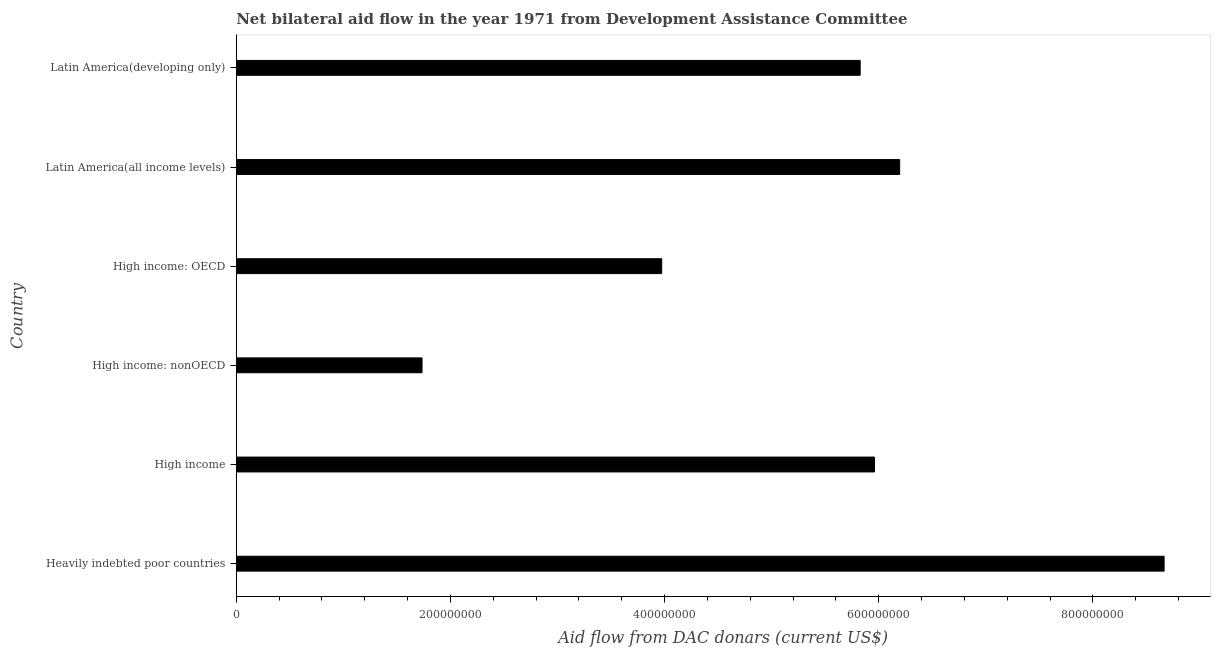What is the title of the graph?
Your answer should be very brief. Net bilateral aid flow in the year 1971 from Development Assistance Committee. What is the label or title of the X-axis?
Your response must be concise. Aid flow from DAC donars (current US$). What is the net bilateral aid flows from dac donors in Latin America(all income levels)?
Your answer should be compact. 6.20e+08. Across all countries, what is the maximum net bilateral aid flows from dac donors?
Your response must be concise. 8.66e+08. Across all countries, what is the minimum net bilateral aid flows from dac donors?
Your answer should be compact. 1.73e+08. In which country was the net bilateral aid flows from dac donors maximum?
Provide a succinct answer. Heavily indebted poor countries. In which country was the net bilateral aid flows from dac donors minimum?
Offer a very short reply. High income: nonOECD. What is the sum of the net bilateral aid flows from dac donors?
Keep it short and to the point. 3.24e+09. What is the difference between the net bilateral aid flows from dac donors in High income: nonOECD and Latin America(developing only)?
Provide a succinct answer. -4.09e+08. What is the average net bilateral aid flows from dac donors per country?
Your answer should be compact. 5.39e+08. What is the median net bilateral aid flows from dac donors?
Your answer should be very brief. 5.89e+08. What is the ratio of the net bilateral aid flows from dac donors in High income: nonOECD to that in Latin America(developing only)?
Offer a terse response. 0.3. What is the difference between the highest and the second highest net bilateral aid flows from dac donors?
Ensure brevity in your answer.  2.47e+08. Is the sum of the net bilateral aid flows from dac donors in High income: OECD and Latin America(all income levels) greater than the maximum net bilateral aid flows from dac donors across all countries?
Provide a succinct answer. Yes. What is the difference between the highest and the lowest net bilateral aid flows from dac donors?
Keep it short and to the point. 6.93e+08. How many bars are there?
Offer a terse response. 6. What is the Aid flow from DAC donars (current US$) in Heavily indebted poor countries?
Keep it short and to the point. 8.66e+08. What is the Aid flow from DAC donars (current US$) in High income?
Keep it short and to the point. 5.96e+08. What is the Aid flow from DAC donars (current US$) in High income: nonOECD?
Provide a succinct answer. 1.73e+08. What is the Aid flow from DAC donars (current US$) of High income: OECD?
Keep it short and to the point. 3.97e+08. What is the Aid flow from DAC donars (current US$) in Latin America(all income levels)?
Your answer should be very brief. 6.20e+08. What is the Aid flow from DAC donars (current US$) of Latin America(developing only)?
Offer a terse response. 5.83e+08. What is the difference between the Aid flow from DAC donars (current US$) in Heavily indebted poor countries and High income?
Give a very brief answer. 2.70e+08. What is the difference between the Aid flow from DAC donars (current US$) in Heavily indebted poor countries and High income: nonOECD?
Keep it short and to the point. 6.93e+08. What is the difference between the Aid flow from DAC donars (current US$) in Heavily indebted poor countries and High income: OECD?
Offer a very short reply. 4.69e+08. What is the difference between the Aid flow from DAC donars (current US$) in Heavily indebted poor countries and Latin America(all income levels)?
Your answer should be compact. 2.47e+08. What is the difference between the Aid flow from DAC donars (current US$) in Heavily indebted poor countries and Latin America(developing only)?
Provide a short and direct response. 2.84e+08. What is the difference between the Aid flow from DAC donars (current US$) in High income and High income: nonOECD?
Offer a very short reply. 4.23e+08. What is the difference between the Aid flow from DAC donars (current US$) in High income and High income: OECD?
Provide a short and direct response. 1.99e+08. What is the difference between the Aid flow from DAC donars (current US$) in High income and Latin America(all income levels)?
Provide a succinct answer. -2.35e+07. What is the difference between the Aid flow from DAC donars (current US$) in High income and Latin America(developing only)?
Your answer should be compact. 1.34e+07. What is the difference between the Aid flow from DAC donars (current US$) in High income: nonOECD and High income: OECD?
Your answer should be very brief. -2.24e+08. What is the difference between the Aid flow from DAC donars (current US$) in High income: nonOECD and Latin America(all income levels)?
Ensure brevity in your answer.  -4.46e+08. What is the difference between the Aid flow from DAC donars (current US$) in High income: nonOECD and Latin America(developing only)?
Your answer should be compact. -4.09e+08. What is the difference between the Aid flow from DAC donars (current US$) in High income: OECD and Latin America(all income levels)?
Provide a succinct answer. -2.22e+08. What is the difference between the Aid flow from DAC donars (current US$) in High income: OECD and Latin America(developing only)?
Keep it short and to the point. -1.85e+08. What is the difference between the Aid flow from DAC donars (current US$) in Latin America(all income levels) and Latin America(developing only)?
Offer a terse response. 3.69e+07. What is the ratio of the Aid flow from DAC donars (current US$) in Heavily indebted poor countries to that in High income?
Your answer should be very brief. 1.45. What is the ratio of the Aid flow from DAC donars (current US$) in Heavily indebted poor countries to that in High income: nonOECD?
Your answer should be compact. 4.99. What is the ratio of the Aid flow from DAC donars (current US$) in Heavily indebted poor countries to that in High income: OECD?
Your response must be concise. 2.18. What is the ratio of the Aid flow from DAC donars (current US$) in Heavily indebted poor countries to that in Latin America(all income levels)?
Offer a very short reply. 1.4. What is the ratio of the Aid flow from DAC donars (current US$) in Heavily indebted poor countries to that in Latin America(developing only)?
Provide a succinct answer. 1.49. What is the ratio of the Aid flow from DAC donars (current US$) in High income to that in High income: nonOECD?
Give a very brief answer. 3.44. What is the ratio of the Aid flow from DAC donars (current US$) in High income to that in Latin America(all income levels)?
Keep it short and to the point. 0.96. What is the ratio of the Aid flow from DAC donars (current US$) in High income: nonOECD to that in High income: OECD?
Give a very brief answer. 0.44. What is the ratio of the Aid flow from DAC donars (current US$) in High income: nonOECD to that in Latin America(all income levels)?
Ensure brevity in your answer.  0.28. What is the ratio of the Aid flow from DAC donars (current US$) in High income: nonOECD to that in Latin America(developing only)?
Give a very brief answer. 0.3. What is the ratio of the Aid flow from DAC donars (current US$) in High income: OECD to that in Latin America(all income levels)?
Provide a short and direct response. 0.64. What is the ratio of the Aid flow from DAC donars (current US$) in High income: OECD to that in Latin America(developing only)?
Ensure brevity in your answer.  0.68. What is the ratio of the Aid flow from DAC donars (current US$) in Latin America(all income levels) to that in Latin America(developing only)?
Provide a short and direct response. 1.06. 